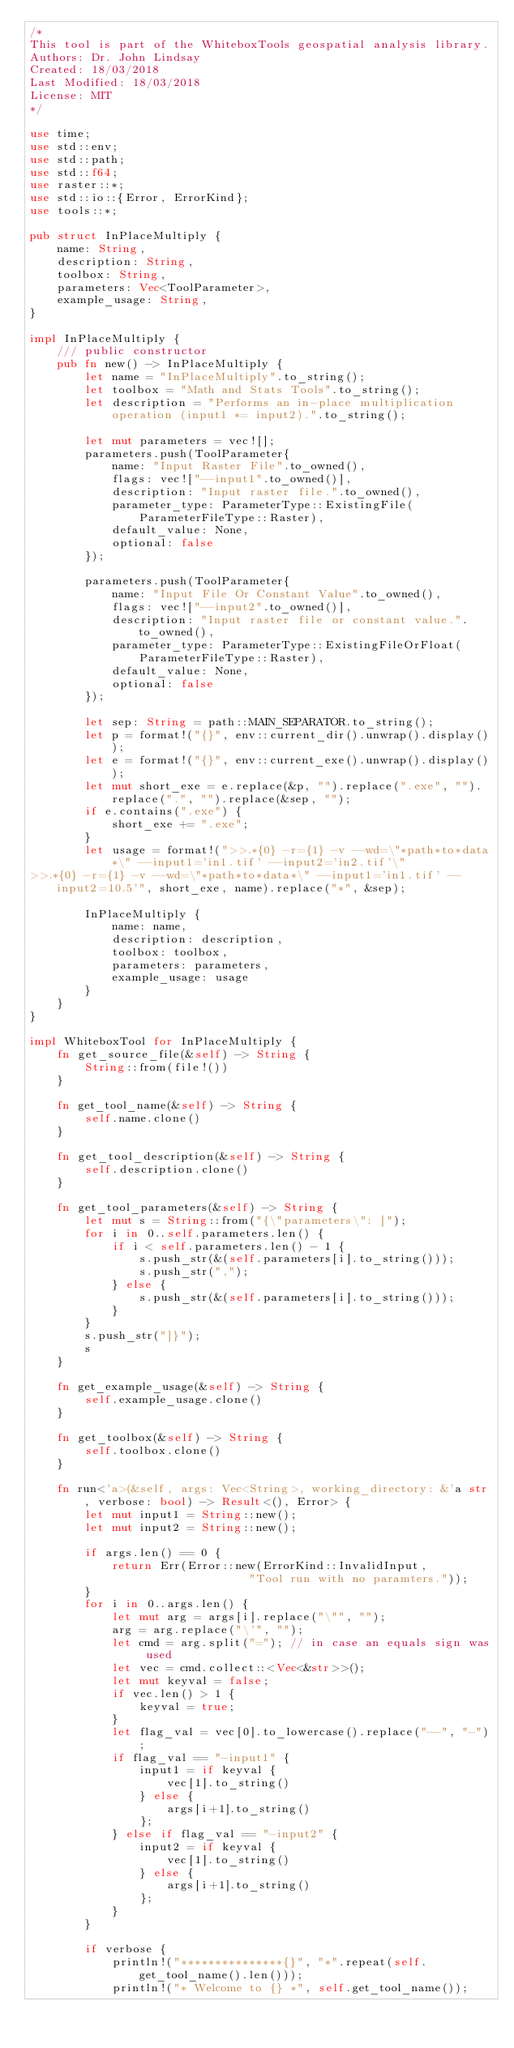<code> <loc_0><loc_0><loc_500><loc_500><_Rust_>/* 
This tool is part of the WhiteboxTools geospatial analysis library.
Authors: Dr. John Lindsay
Created: 18/03/2018
Last Modified: 18/03/2018
License: MIT
*/

use time;
use std::env;
use std::path;
use std::f64;
use raster::*;
use std::io::{Error, ErrorKind};
use tools::*;

pub struct InPlaceMultiply {
    name: String,
    description: String,
    toolbox: String,
    parameters: Vec<ToolParameter>,
    example_usage: String,
}

impl InPlaceMultiply {
    /// public constructor
    pub fn new() -> InPlaceMultiply { 
        let name = "InPlaceMultiply".to_string();
        let toolbox = "Math and Stats Tools".to_string();
        let description = "Performs an in-place multiplication operation (input1 *= input2).".to_string();
        
        let mut parameters = vec![];
        parameters.push(ToolParameter{
            name: "Input Raster File".to_owned(), 
            flags: vec!["--input1".to_owned()], 
            description: "Input raster file.".to_owned(),
            parameter_type: ParameterType::ExistingFile(ParameterFileType::Raster),
            default_value: None,
            optional: false
        });

        parameters.push(ToolParameter{
            name: "Input File Or Constant Value".to_owned(), 
            flags: vec!["--input2".to_owned()], 
            description: "Input raster file or constant value.".to_owned(),
            parameter_type: ParameterType::ExistingFileOrFloat(ParameterFileType::Raster),
            default_value: None,
            optional: false
        });
         
        let sep: String = path::MAIN_SEPARATOR.to_string();
        let p = format!("{}", env::current_dir().unwrap().display());
        let e = format!("{}", env::current_exe().unwrap().display());
        let mut short_exe = e.replace(&p, "").replace(".exe", "").replace(".", "").replace(&sep, "");
        if e.contains(".exe") {
            short_exe += ".exe";
        }
        let usage = format!(">>.*{0} -r={1} -v --wd=\"*path*to*data*\" --input1='in1.tif' --input2='in2.tif'\"
>>.*{0} -r={1} -v --wd=\"*path*to*data*\" --input1='in1.tif' --input2=10.5'", short_exe, name).replace("*", &sep);
    
        InPlaceMultiply { 
            name: name, 
            description: description, 
            toolbox: toolbox,
            parameters: parameters, 
            example_usage: usage 
        }
    }
}

impl WhiteboxTool for InPlaceMultiply {
    fn get_source_file(&self) -> String {
        String::from(file!())
    }
    
    fn get_tool_name(&self) -> String {
        self.name.clone()
    }

    fn get_tool_description(&self) -> String {
        self.description.clone()
    }

    fn get_tool_parameters(&self) -> String {
        let mut s = String::from("{\"parameters\": [");
        for i in 0..self.parameters.len() {
            if i < self.parameters.len() - 1 {
                s.push_str(&(self.parameters[i].to_string()));
                s.push_str(",");
            } else {
                s.push_str(&(self.parameters[i].to_string()));
            }
        }
        s.push_str("]}");
        s
    }

    fn get_example_usage(&self) -> String {
        self.example_usage.clone()
    }

    fn get_toolbox(&self) -> String {
        self.toolbox.clone()
    }

    fn run<'a>(&self, args: Vec<String>, working_directory: &'a str, verbose: bool) -> Result<(), Error> {
        let mut input1 = String::new();
        let mut input2 = String::new();
         
        if args.len() == 0 {
            return Err(Error::new(ErrorKind::InvalidInput,
                                "Tool run with no paramters."));
        }
        for i in 0..args.len() {
            let mut arg = args[i].replace("\"", "");
            arg = arg.replace("\'", "");
            let cmd = arg.split("="); // in case an equals sign was used
            let vec = cmd.collect::<Vec<&str>>();
            let mut keyval = false;
            if vec.len() > 1 {
                keyval = true;
            }
            let flag_val = vec[0].to_lowercase().replace("--", "-");
            if flag_val == "-input1" {
                input1 = if keyval {
                    vec[1].to_string()
                } else {
                    args[i+1].to_string()
                };
            } else if flag_val == "-input2" {
                input2 = if keyval {
                    vec[1].to_string()
                } else {
                    args[i+1].to_string()
                };
            }
        }

        if verbose {
            println!("***************{}", "*".repeat(self.get_tool_name().len()));
            println!("* Welcome to {} *", self.get_tool_name());</code> 